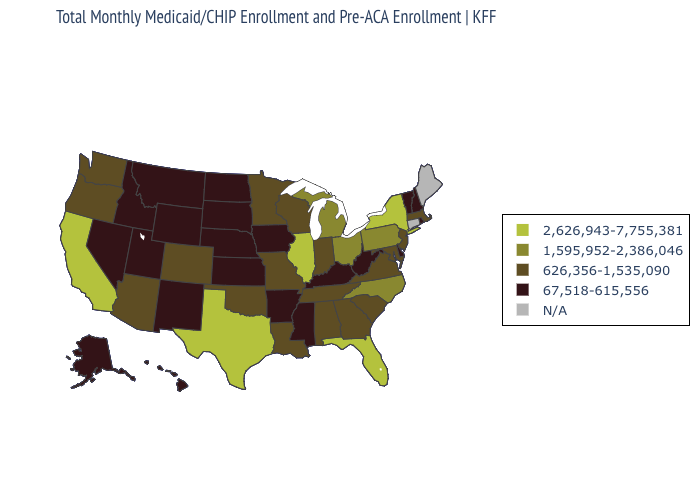What is the value of Kentucky?
Answer briefly. 67,518-615,556. What is the value of New Mexico?
Answer briefly. 67,518-615,556. Does the first symbol in the legend represent the smallest category?
Answer briefly. No. Does New York have the lowest value in the USA?
Write a very short answer. No. Does California have the highest value in the West?
Give a very brief answer. Yes. What is the value of Florida?
Write a very short answer. 2,626,943-7,755,381. Name the states that have a value in the range 67,518-615,556?
Short answer required. Alaska, Arkansas, Delaware, Hawaii, Idaho, Iowa, Kansas, Kentucky, Mississippi, Montana, Nebraska, Nevada, New Hampshire, New Mexico, North Dakota, Rhode Island, South Dakota, Utah, Vermont, West Virginia, Wyoming. Which states have the highest value in the USA?
Answer briefly. California, Florida, Illinois, New York, Texas. Does the first symbol in the legend represent the smallest category?
Keep it brief. No. Does Pennsylvania have the highest value in the Northeast?
Short answer required. No. What is the highest value in states that border Minnesota?
Concise answer only. 626,356-1,535,090. Name the states that have a value in the range 67,518-615,556?
Keep it brief. Alaska, Arkansas, Delaware, Hawaii, Idaho, Iowa, Kansas, Kentucky, Mississippi, Montana, Nebraska, Nevada, New Hampshire, New Mexico, North Dakota, Rhode Island, South Dakota, Utah, Vermont, West Virginia, Wyoming. Among the states that border Rhode Island , which have the highest value?
Concise answer only. Massachusetts. Name the states that have a value in the range 626,356-1,535,090?
Concise answer only. Alabama, Arizona, Colorado, Georgia, Indiana, Louisiana, Maryland, Massachusetts, Minnesota, Missouri, New Jersey, Oklahoma, Oregon, South Carolina, Tennessee, Virginia, Washington, Wisconsin. Does the first symbol in the legend represent the smallest category?
Concise answer only. No. 